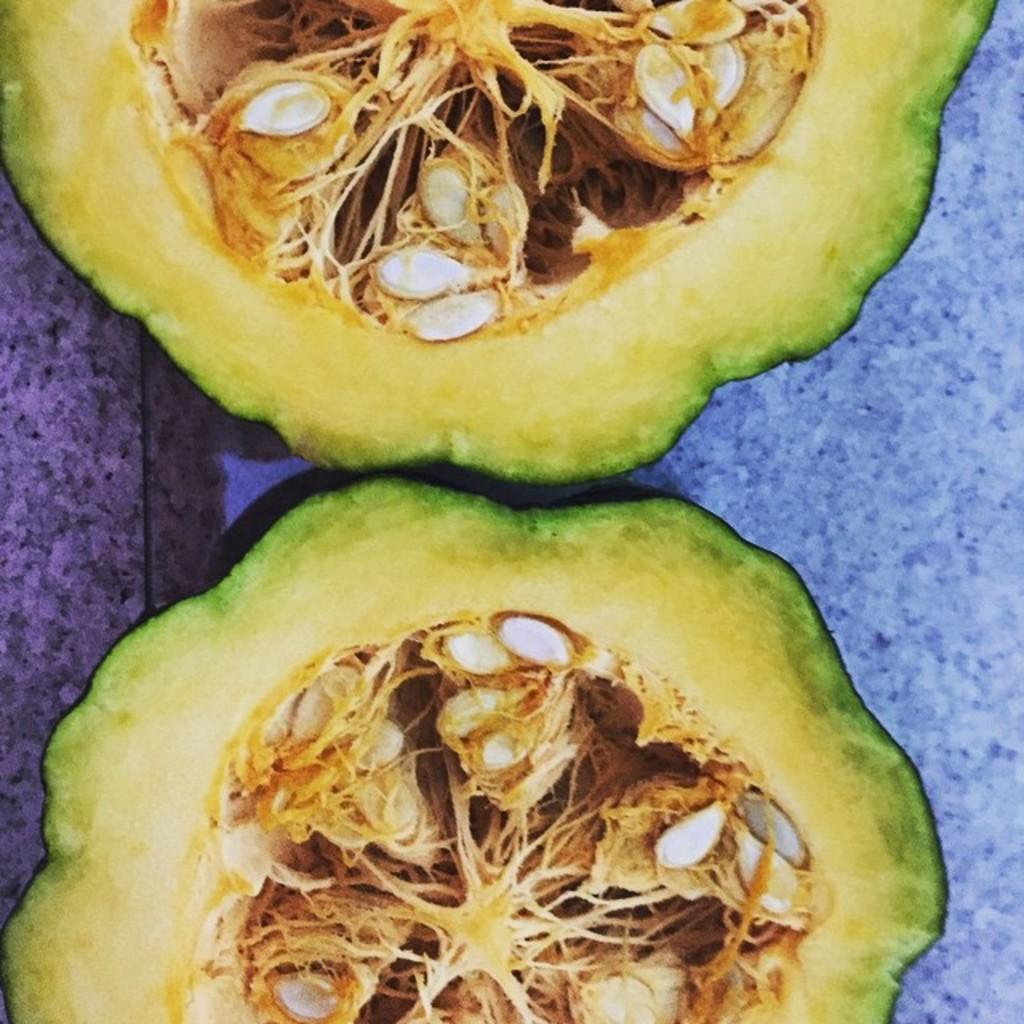How would you summarize this image in a sentence or two? In this picture we can see two pieces of pumpkins, inside them we can see seeds. On the right we can see a blue color object. 